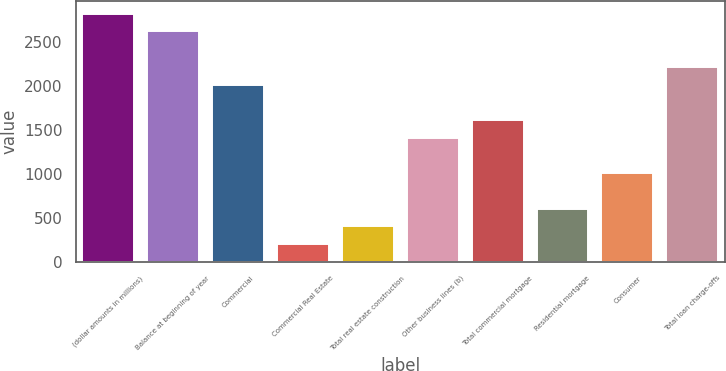Convert chart. <chart><loc_0><loc_0><loc_500><loc_500><bar_chart><fcel>(dollar amounts in millions)<fcel>Balance at beginning of year<fcel>Commercial<fcel>Commercial Real Estate<fcel>Total real estate construction<fcel>Other business lines (b)<fcel>Total commercial mortgage<fcel>Residential mortgage<fcel>Consumer<fcel>Total loan charge-offs<nl><fcel>2818.08<fcel>2616.8<fcel>2012.96<fcel>201.44<fcel>402.72<fcel>1409.12<fcel>1610.4<fcel>604<fcel>1006.56<fcel>2214.24<nl></chart> 